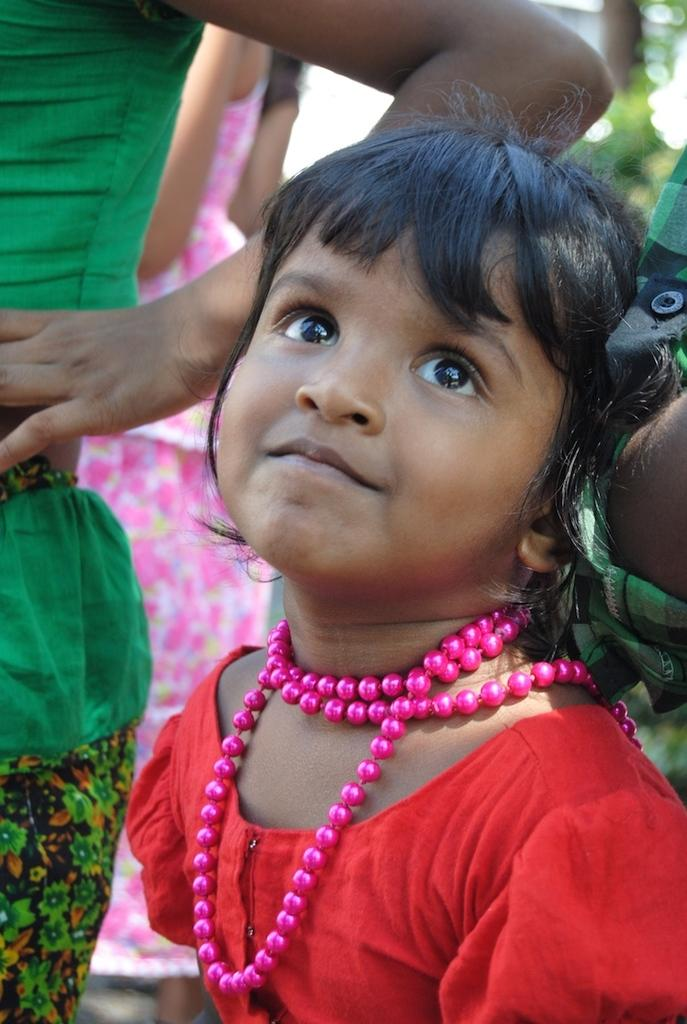Who is the main subject in the image? There is a girl in the image. What is the girl doing in the image? The girl is looking to one side. What is the girl wearing in the image? The girl is wearing a red color top and a pink color neck chain. Are there any other people in the image? Yes, there are other people in the image. What type of teeth can be seen in the image? There is no reference to teeth in the image, as it features a girl and other people. 